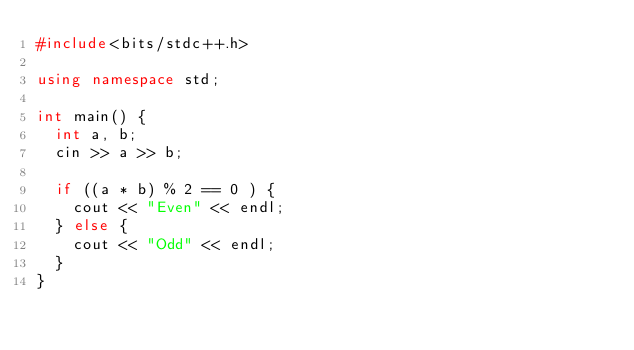<code> <loc_0><loc_0><loc_500><loc_500><_C++_>#include<bits/stdc++.h>

using namespace std;

int main() {
  int a, b;
  cin >> a >> b;

  if ((a * b) % 2 == 0 ) {
    cout << "Even" << endl;
  } else {
    cout << "Odd" << endl;
  }
}</code> 